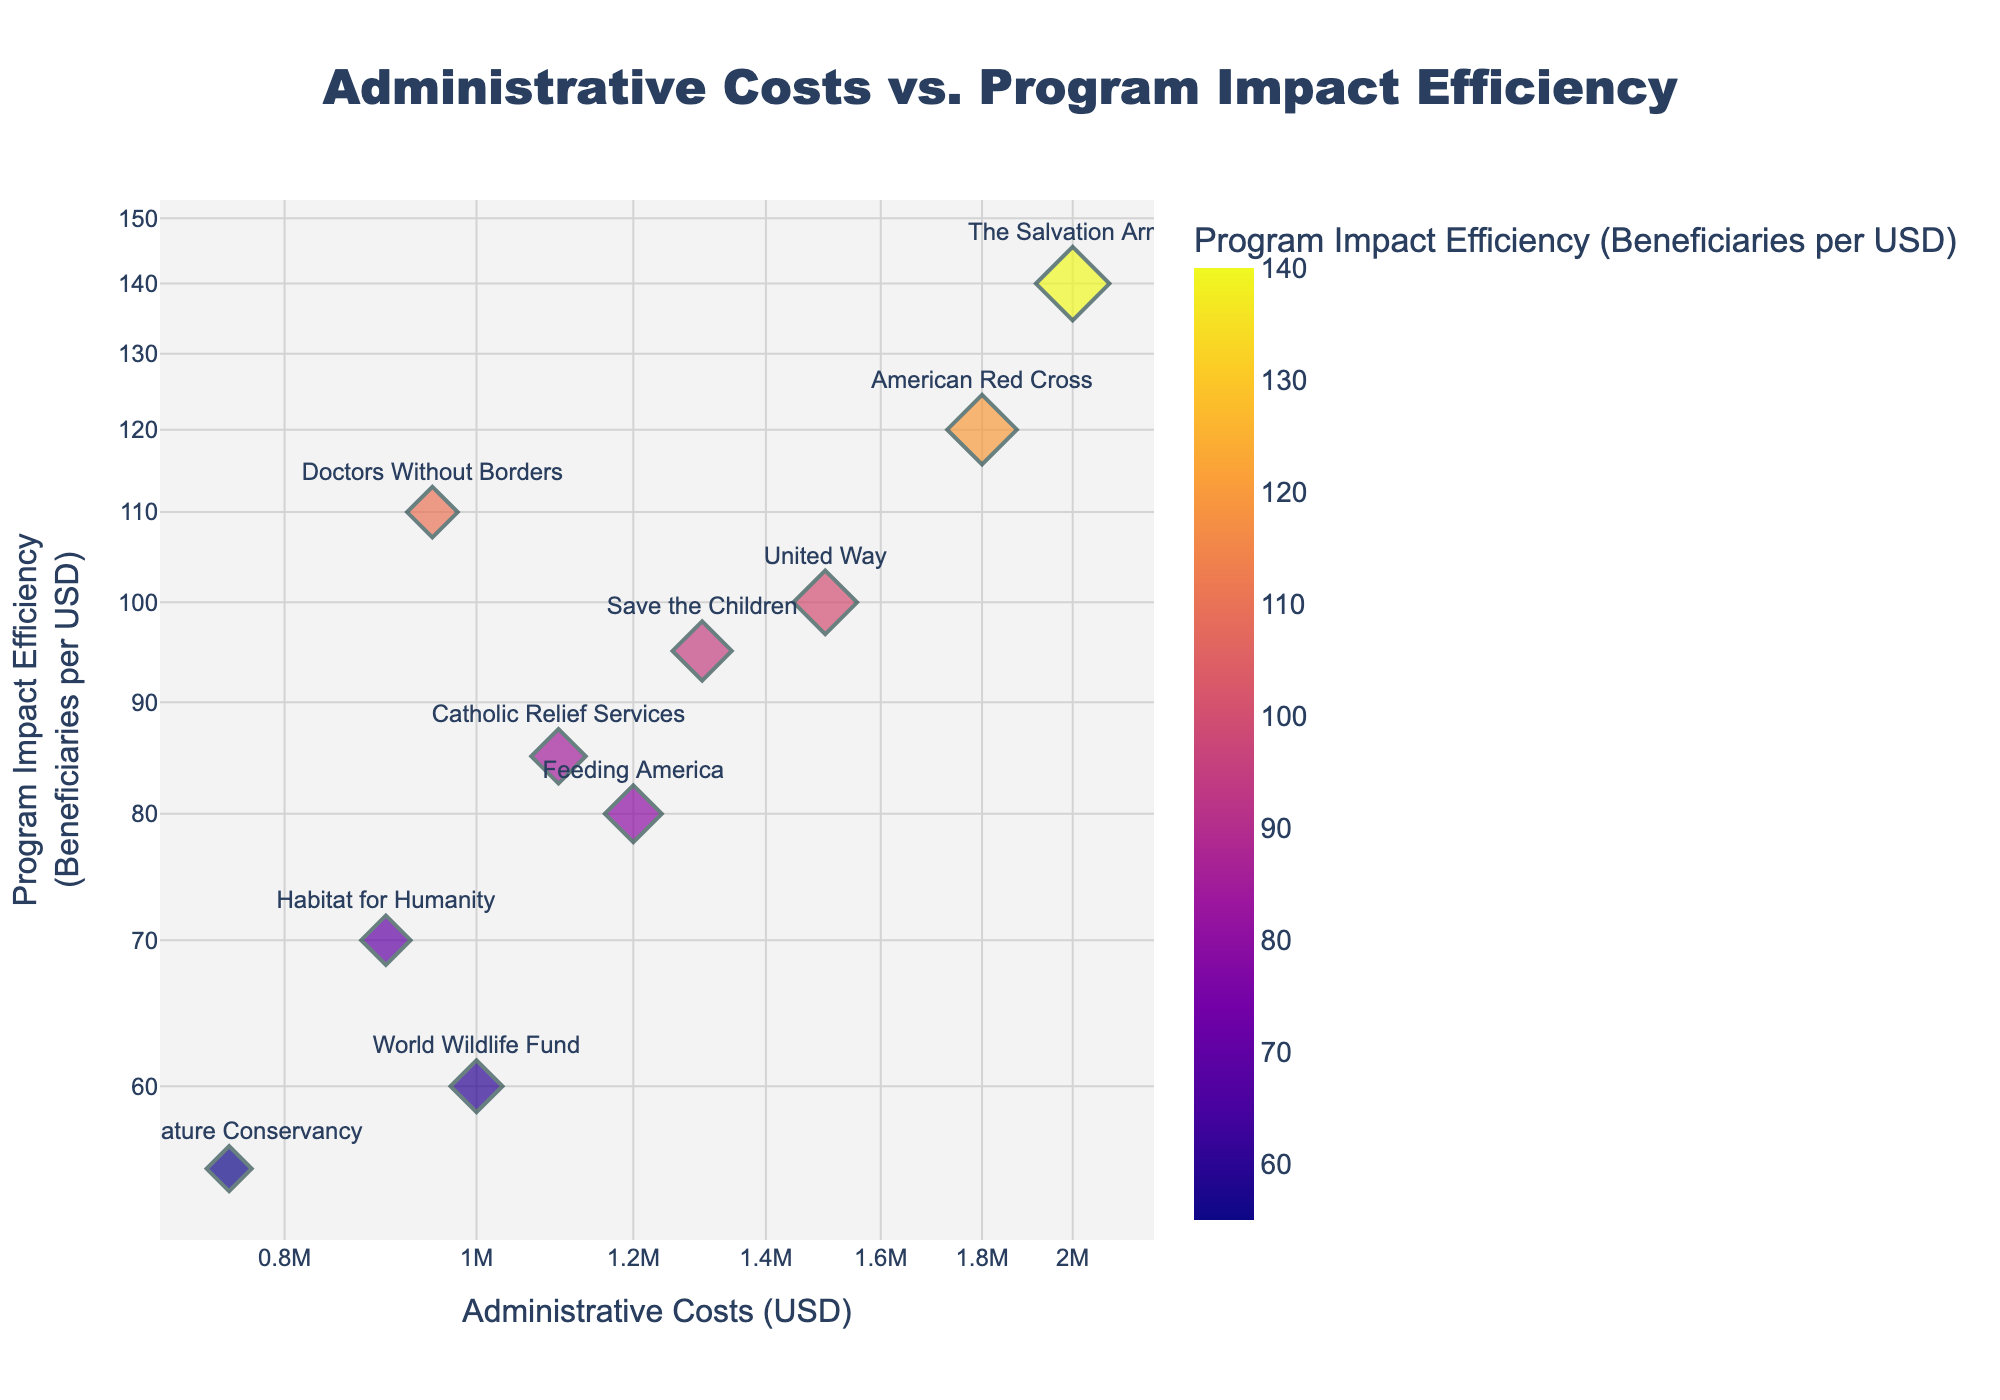What is the title of the scatter plot? The title of the scatter plot is displayed prominently at the top center of the figure. It reads 'Administrative Costs vs. Program Impact Efficiency'.
Answer: Administrative Costs vs. Program Impact Efficiency Which organization has the highest program impact efficiency? By looking at the y-axis, which represents Program Impact Efficiency, and finding the highest point along that axis, we can see that The Salvation Army has the highest value of program impact efficiency.
Answer: The Salvation Army What is the x-axis label and the y-axis label? The x-axis label is printed horizontally below the x-axis, and the y-axis label is printed vertically along the y-axis. They are ‘Administrative Costs (USD)’ and ‘Program Impact Efficiency (Beneficiaries per USD)’, respectively.
Answer: x-axis: Administrative Costs (USD); y-axis: Program Impact Efficiency (Beneficiaries per USD) How many organizations have administrative costs less than $1,000,000? The x-axis uses a log scale, so we look for points positioned to the left of the $1,000,000 mark. The organizations are Habitat for Humanity, Doctors Without Borders, World Wildlife Fund, and The Nature Conservancy.
Answer: Four organizations Which organization has the smallest administrative costs and what is its program impact efficiency? The smallest administrative costs correspond to the lowest value on the x-axis, which is for The Nature Conservancy. By checking its position on the y-axis, it shows a program impact efficiency of 55 beneficiaries per USD.
Answer: The Nature Conservancy, 55 beneficiaries per USD Compare the administrative costs and program impact efficiency of United Way and American Red Cross. Which organization has higher values? United Way's administrative costs are $1,500,000 with a program impact efficiency of 100 beneficiaries per USD, while American Red Cross has administrative costs of $1,800,000 and a program impact efficiency of 120 beneficiaries per USD. American Red Cross has higher administrative costs and higher program impact efficiency.
Answer: American Red Cross What is the average program impact efficiency of organizations with administrative costs over $1,000,000? Organizations with administrative costs over $1,000,000 are United Way (100), Feeding America (80), American Red Cross (120), Save the Children (95), The Salvation Army (140), Catholic Relief Services (85). Adding their efficiencies gives (100 + 80 + 120 + 95 + 140 + 85) = 620. Dividing by the number of organizations (6), the average program impact efficiency is 620/6 ≈ 103.33.
Answer: 103.33 Identify the two organizations with closest program impact efficiencies and calculate their difference. From the figure, Feeding America (80) and Catholic Relief Services (85) have the closest program impact efficiencies. The difference is 85 - 80 = 5.
Answer: 5 beneficiaries per USD How does the scatter plot help in identifying cost-effectiveness among organizations? The log-log scatter plot allows us to compare administrative costs and program impact efficiency simultaneously, providing a visual method to gauge which organizations achieve higher impact with lower costs. Highly efficient programs with low administrative costs will stand out clearly in the lower-right region of the plot.
Answer: Visual comparison on log-log scatter plot If an organization aims to increase its program impact efficiency by 10%, where should they aim to position on the y-axis? To increase program impact efficiency by 10%, the organization should move up by 10% from their current y-axis value. This aims to show an increased number of beneficiaries per USD. For example, if an organization currently has a program impact efficiency of 100, they should aim for 110 beneficiaries per USD.
Answer: 10% higher on the y-axis 